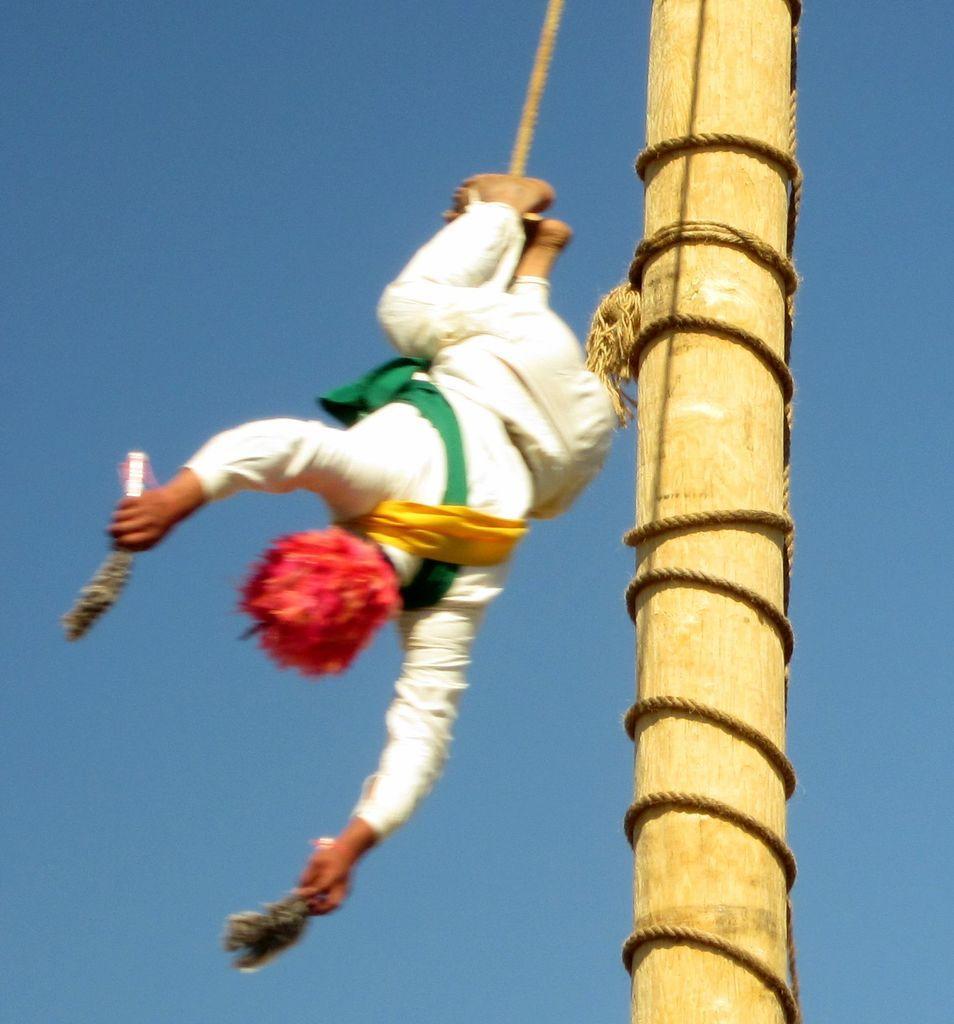Describe this image in one or two sentences. In the image there is a wooden pole and a person is falling down by tying a rope to that pole, he is holding some objects with his both hands. 